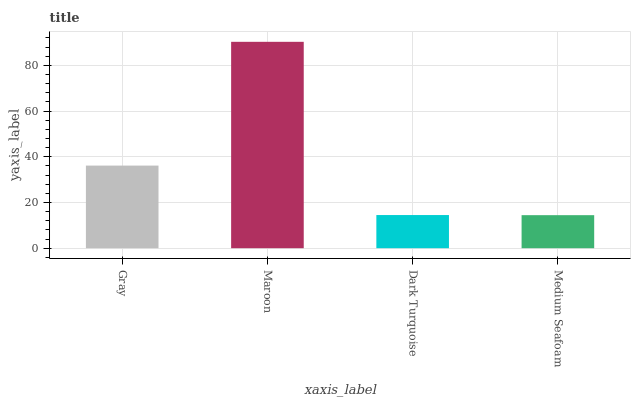Is Medium Seafoam the minimum?
Answer yes or no. Yes. Is Maroon the maximum?
Answer yes or no. Yes. Is Dark Turquoise the minimum?
Answer yes or no. No. Is Dark Turquoise the maximum?
Answer yes or no. No. Is Maroon greater than Dark Turquoise?
Answer yes or no. Yes. Is Dark Turquoise less than Maroon?
Answer yes or no. Yes. Is Dark Turquoise greater than Maroon?
Answer yes or no. No. Is Maroon less than Dark Turquoise?
Answer yes or no. No. Is Gray the high median?
Answer yes or no. Yes. Is Dark Turquoise the low median?
Answer yes or no. Yes. Is Dark Turquoise the high median?
Answer yes or no. No. Is Medium Seafoam the low median?
Answer yes or no. No. 